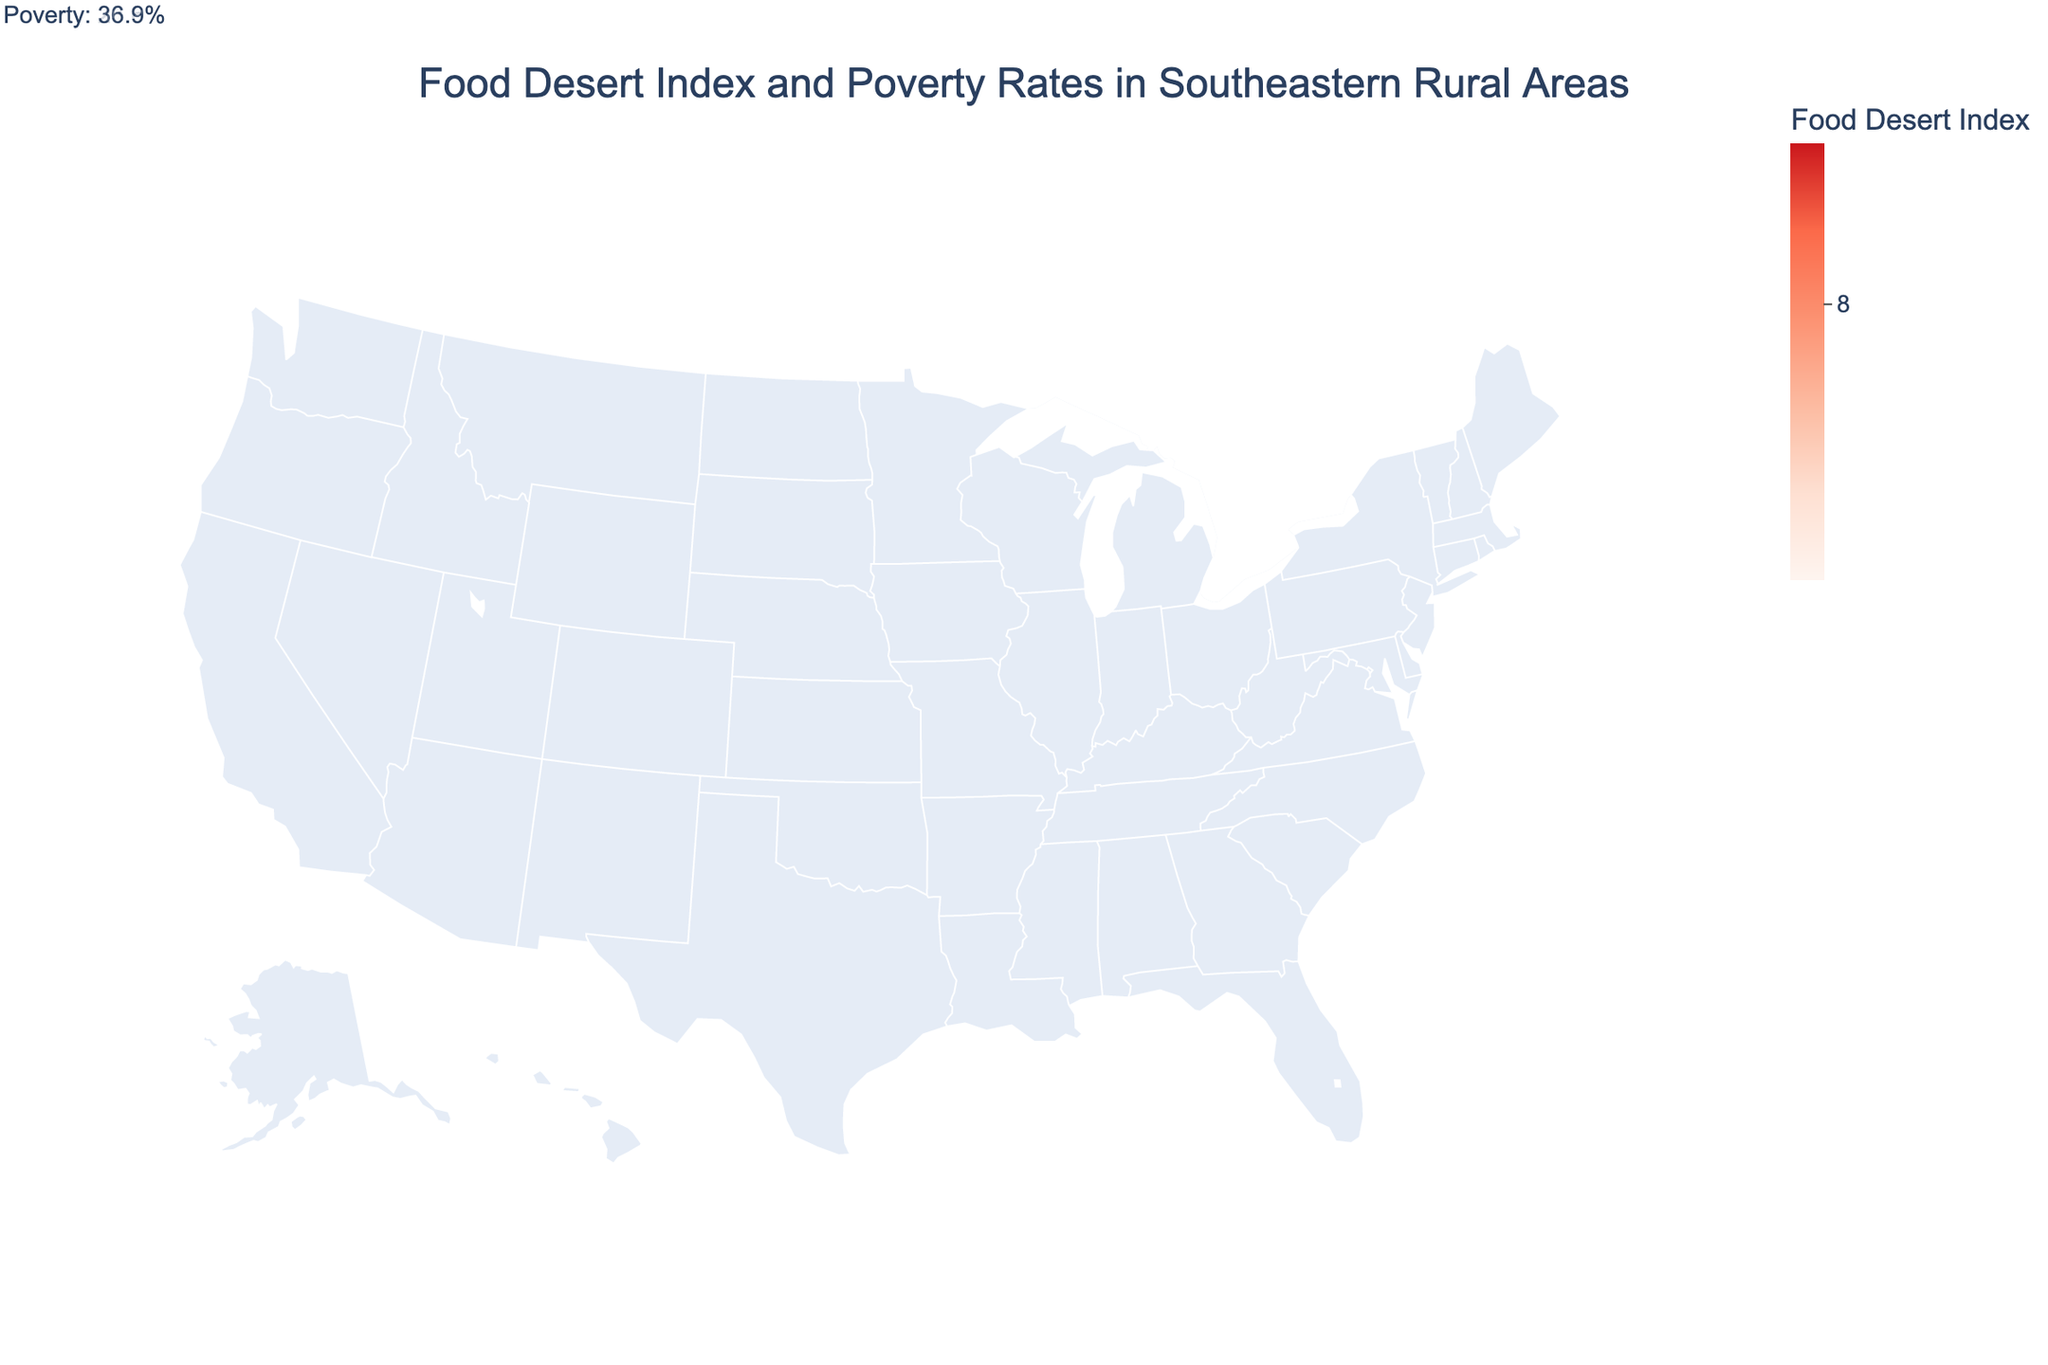Which county has the highest Food Desert Index? Look at the color legend and identify the darkest shade on the map, then identify the corresponding county.
Answer: Issaquena, Mississippi What is the relationship between the Food Desert Index and Poverty Rate in Holmes, Mississippi? Locate Holmes, Mississippi on the map and refer to its annotation to identify both metrics. Holmes has a Food Desert Index of 8.5 and a Poverty Rate of 35.2%.
Answer: Both are high Which state appears most frequently in the dataset? Count the occurrences of each state name in the dataset and identify the state with the most mentions.
Answer: Mississippi Which county has the lowest Poverty Rate and what is it? Scan the figure annotations to identify the county with the lowest poverty rate.
Answer: Sumter, Florida with 18.6% Is there a general trend visible between the Food Desert Index and Poverty Rates in the counties shown? Analyze the correlation by comparing both metrics for each county indicated on the annotations. Higher Food Desert Index tends to correspond with higher poverty rates.
Answer: Positive correlation How many counties have a Food Desert Index greater than 8.0? Count the counties in the figure where the Food Desert Index is greater than 8.0.
Answer: Five counties Which of the counties in South Carolina has the higher Food Desert Index? Find the two counties in South Carolina on the map and compare their Food Desert Index values.
Answer: Allendale with 8.1, compared to Marlboro with 7.8 What is the average Poverty Rate of the counties in the figure? Sum up all the Poverty Rate values and divide by the number of counties. [(30.5 + 28.7 + 35.2 + 31.3 + 25.9 + 18.6 + 22.4 + 29.8 + 24.1 + 32.7 + 27.5 + 33.1 + 21.8 + 23.6 + 36.9) / 15]
Answer: 28.4% Between Alabama and Arkansas, which has the county with a higher Food Desert Index? Compare the Food Desert Index of Wilcox, Alabama (8.2) and Lee, Arkansas (8.0).
Answer: Alabama with 8.2 